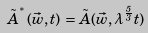<formula> <loc_0><loc_0><loc_500><loc_500>\tilde { A } ^ { ^ { * } } ( \vec { w } , t ) \, = \, \tilde { A } ( \vec { w } , \lambda ^ { \frac { 5 } { 3 } } t )</formula> 